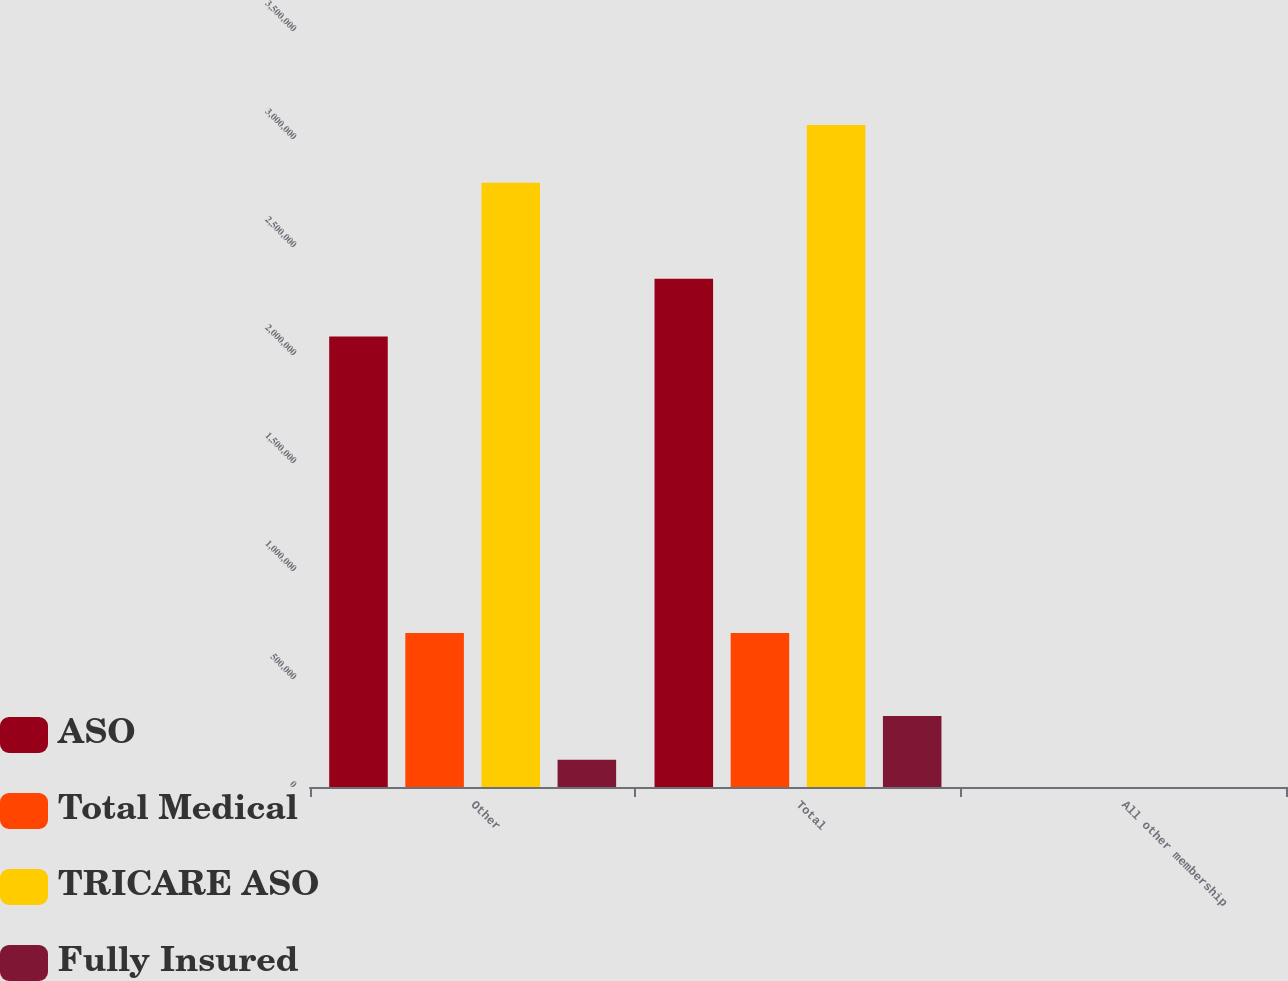Convert chart to OTSL. <chart><loc_0><loc_0><loc_500><loc_500><stacked_bar_chart><ecel><fcel>Other<fcel>Total<fcel>All other membership<nl><fcel>ASO<fcel>2.0851e+06<fcel>2.3528e+06<fcel>88.7<nl><fcel>Total Medical<fcel>712400<fcel>712400<fcel>100<nl><fcel>TRICARE ASO<fcel>2.7975e+06<fcel>3.0652e+06<fcel>91.3<nl><fcel>Fully Insured<fcel>126400<fcel>328600<fcel>38.5<nl></chart> 